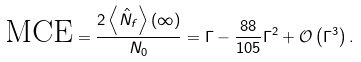Convert formula to latex. <formula><loc_0><loc_0><loc_500><loc_500>\text {MCE} = \frac { 2 \left \langle \hat { N } _ { f } \right \rangle \left ( \infty \right ) } { N _ { 0 } } = \Gamma - \frac { 8 8 } { 1 0 5 } \Gamma ^ { 2 } + \mathcal { O } \left ( \Gamma ^ { 3 } \right ) .</formula> 